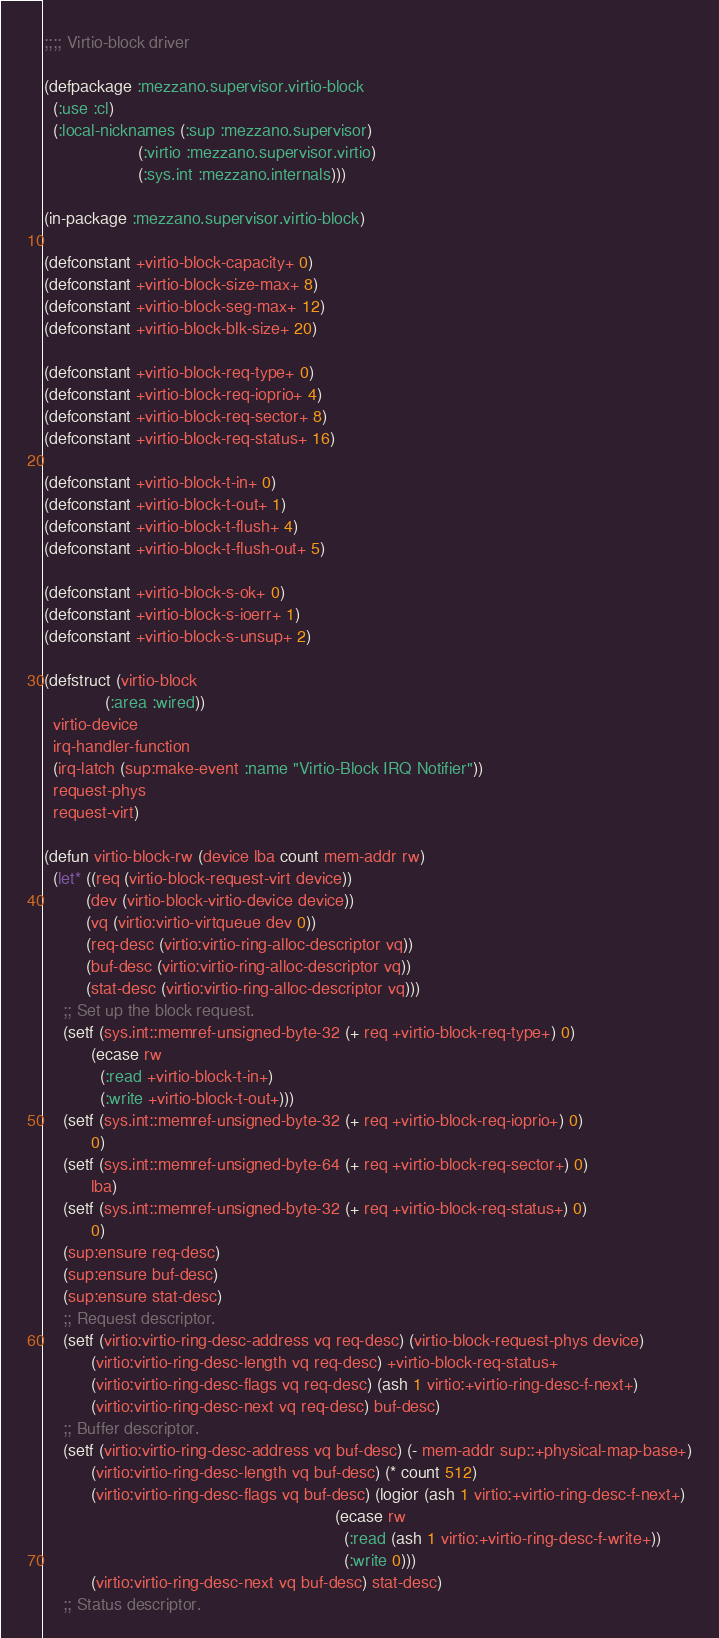Convert code to text. <code><loc_0><loc_0><loc_500><loc_500><_Lisp_>;;;; Virtio-block driver

(defpackage :mezzano.supervisor.virtio-block
  (:use :cl)
  (:local-nicknames (:sup :mezzano.supervisor)
                    (:virtio :mezzano.supervisor.virtio)
                    (:sys.int :mezzano.internals)))

(in-package :mezzano.supervisor.virtio-block)

(defconstant +virtio-block-capacity+ 0)
(defconstant +virtio-block-size-max+ 8)
(defconstant +virtio-block-seg-max+ 12)
(defconstant +virtio-block-blk-size+ 20)

(defconstant +virtio-block-req-type+ 0)
(defconstant +virtio-block-req-ioprio+ 4)
(defconstant +virtio-block-req-sector+ 8)
(defconstant +virtio-block-req-status+ 16)

(defconstant +virtio-block-t-in+ 0)
(defconstant +virtio-block-t-out+ 1)
(defconstant +virtio-block-t-flush+ 4)
(defconstant +virtio-block-t-flush-out+ 5)

(defconstant +virtio-block-s-ok+ 0)
(defconstant +virtio-block-s-ioerr+ 1)
(defconstant +virtio-block-s-unsup+ 2)

(defstruct (virtio-block
             (:area :wired))
  virtio-device
  irq-handler-function
  (irq-latch (sup:make-event :name "Virtio-Block IRQ Notifier"))
  request-phys
  request-virt)

(defun virtio-block-rw (device lba count mem-addr rw)
  (let* ((req (virtio-block-request-virt device))
         (dev (virtio-block-virtio-device device))
         (vq (virtio:virtio-virtqueue dev 0))
         (req-desc (virtio:virtio-ring-alloc-descriptor vq))
         (buf-desc (virtio:virtio-ring-alloc-descriptor vq))
         (stat-desc (virtio:virtio-ring-alloc-descriptor vq)))
    ;; Set up the block request.
    (setf (sys.int::memref-unsigned-byte-32 (+ req +virtio-block-req-type+) 0)
          (ecase rw
            (:read +virtio-block-t-in+)
            (:write +virtio-block-t-out+)))
    (setf (sys.int::memref-unsigned-byte-32 (+ req +virtio-block-req-ioprio+) 0)
          0)
    (setf (sys.int::memref-unsigned-byte-64 (+ req +virtio-block-req-sector+) 0)
          lba)
    (setf (sys.int::memref-unsigned-byte-32 (+ req +virtio-block-req-status+) 0)
          0)
    (sup:ensure req-desc)
    (sup:ensure buf-desc)
    (sup:ensure stat-desc)
    ;; Request descriptor.
    (setf (virtio:virtio-ring-desc-address vq req-desc) (virtio-block-request-phys device)
          (virtio:virtio-ring-desc-length vq req-desc) +virtio-block-req-status+
          (virtio:virtio-ring-desc-flags vq req-desc) (ash 1 virtio:+virtio-ring-desc-f-next+)
          (virtio:virtio-ring-desc-next vq req-desc) buf-desc)
    ;; Buffer descriptor.
    (setf (virtio:virtio-ring-desc-address vq buf-desc) (- mem-addr sup::+physical-map-base+)
          (virtio:virtio-ring-desc-length vq buf-desc) (* count 512)
          (virtio:virtio-ring-desc-flags vq buf-desc) (logior (ash 1 virtio:+virtio-ring-desc-f-next+)
                                                              (ecase rw
                                                                (:read (ash 1 virtio:+virtio-ring-desc-f-write+))
                                                                (:write 0)))
          (virtio:virtio-ring-desc-next vq buf-desc) stat-desc)
    ;; Status descriptor.</code> 